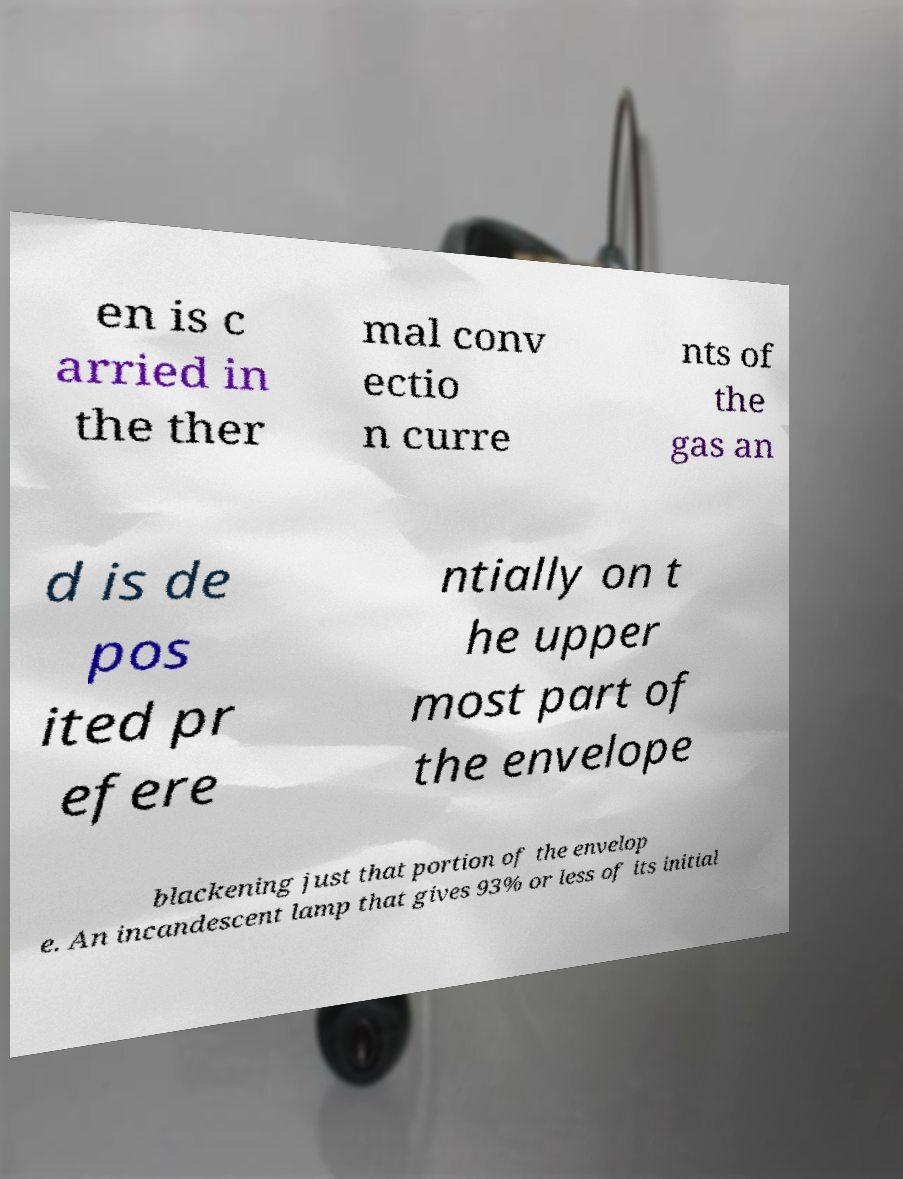Could you extract and type out the text from this image? en is c arried in the ther mal conv ectio n curre nts of the gas an d is de pos ited pr efere ntially on t he upper most part of the envelope blackening just that portion of the envelop e. An incandescent lamp that gives 93% or less of its initial 